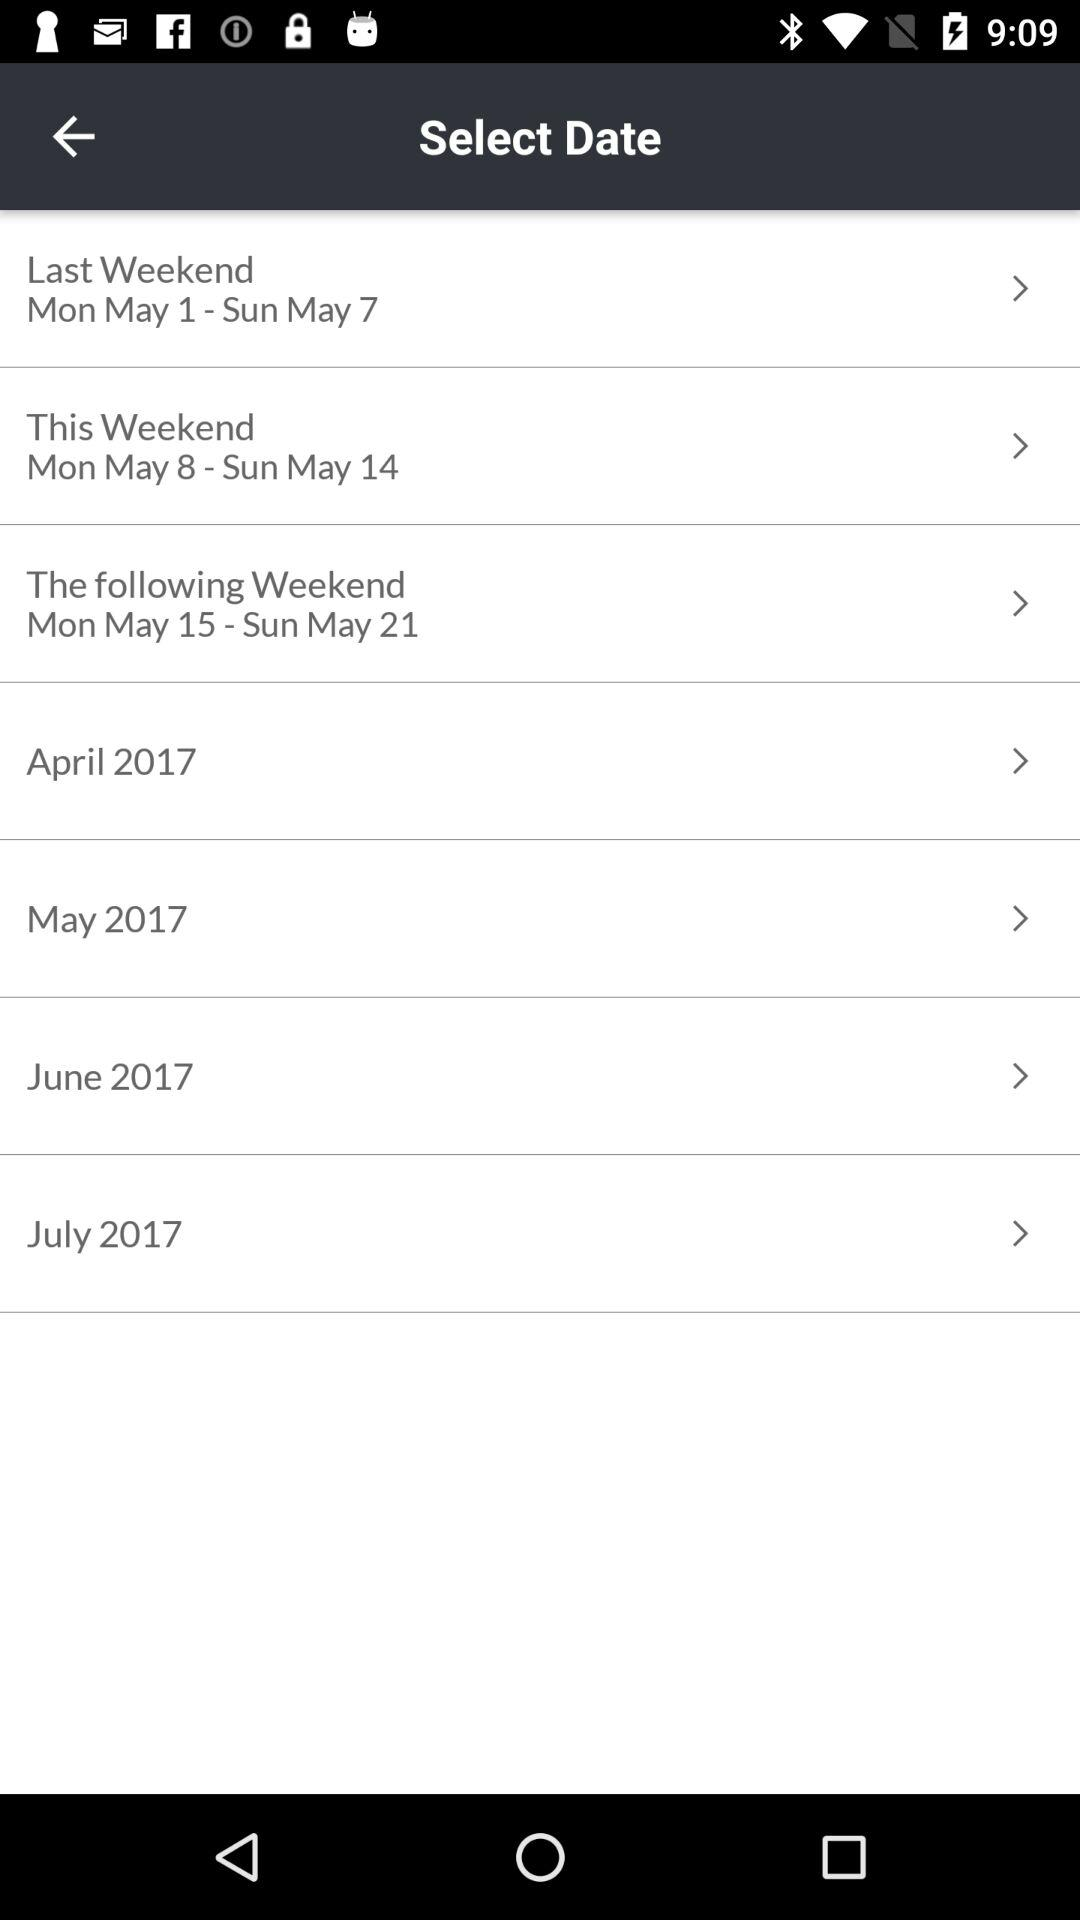Which day falls on May 15? The day is Monday. 